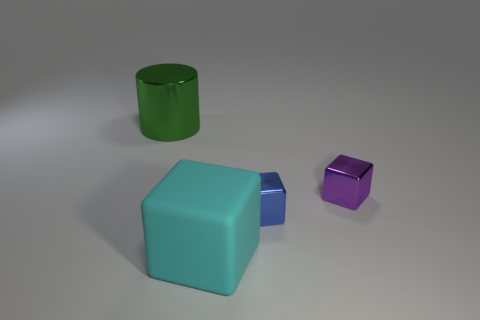Is there a possible theme or concept being conveyed by the arrangement of these objects? The arrangement might be interpreted as a study of geometric shapes and colors, potentially serving as a visual prompt for a discussion about 3D objects and their properties. 